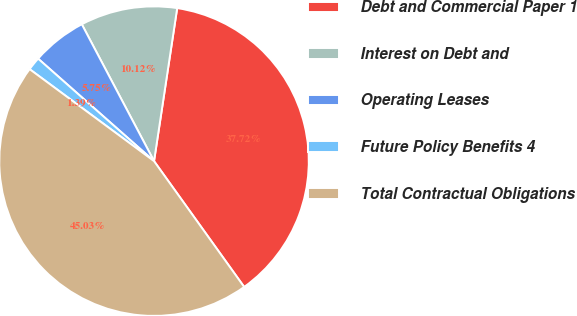<chart> <loc_0><loc_0><loc_500><loc_500><pie_chart><fcel>Debt and Commercial Paper 1<fcel>Interest on Debt and<fcel>Operating Leases<fcel>Future Policy Benefits 4<fcel>Total Contractual Obligations<nl><fcel>37.72%<fcel>10.12%<fcel>5.75%<fcel>1.39%<fcel>45.03%<nl></chart> 